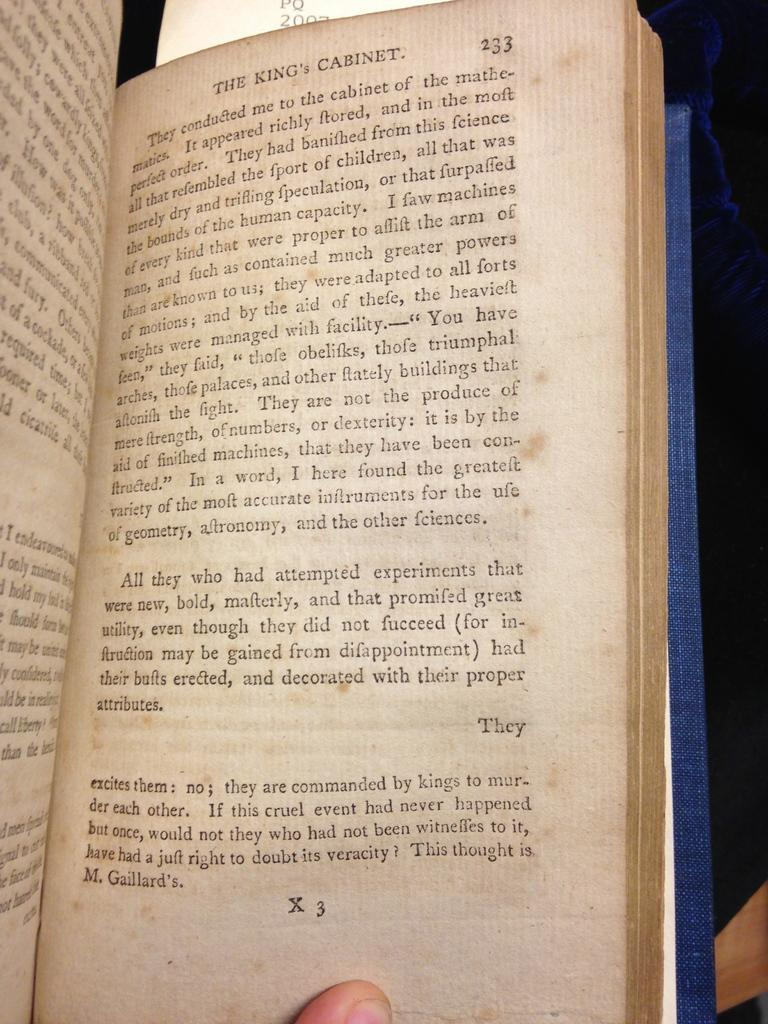<image>
Relay a brief, clear account of the picture shown. a book that says 'the kings cabinet' at the top of it 